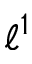<formula> <loc_0><loc_0><loc_500><loc_500>\ell ^ { 1 }</formula> 